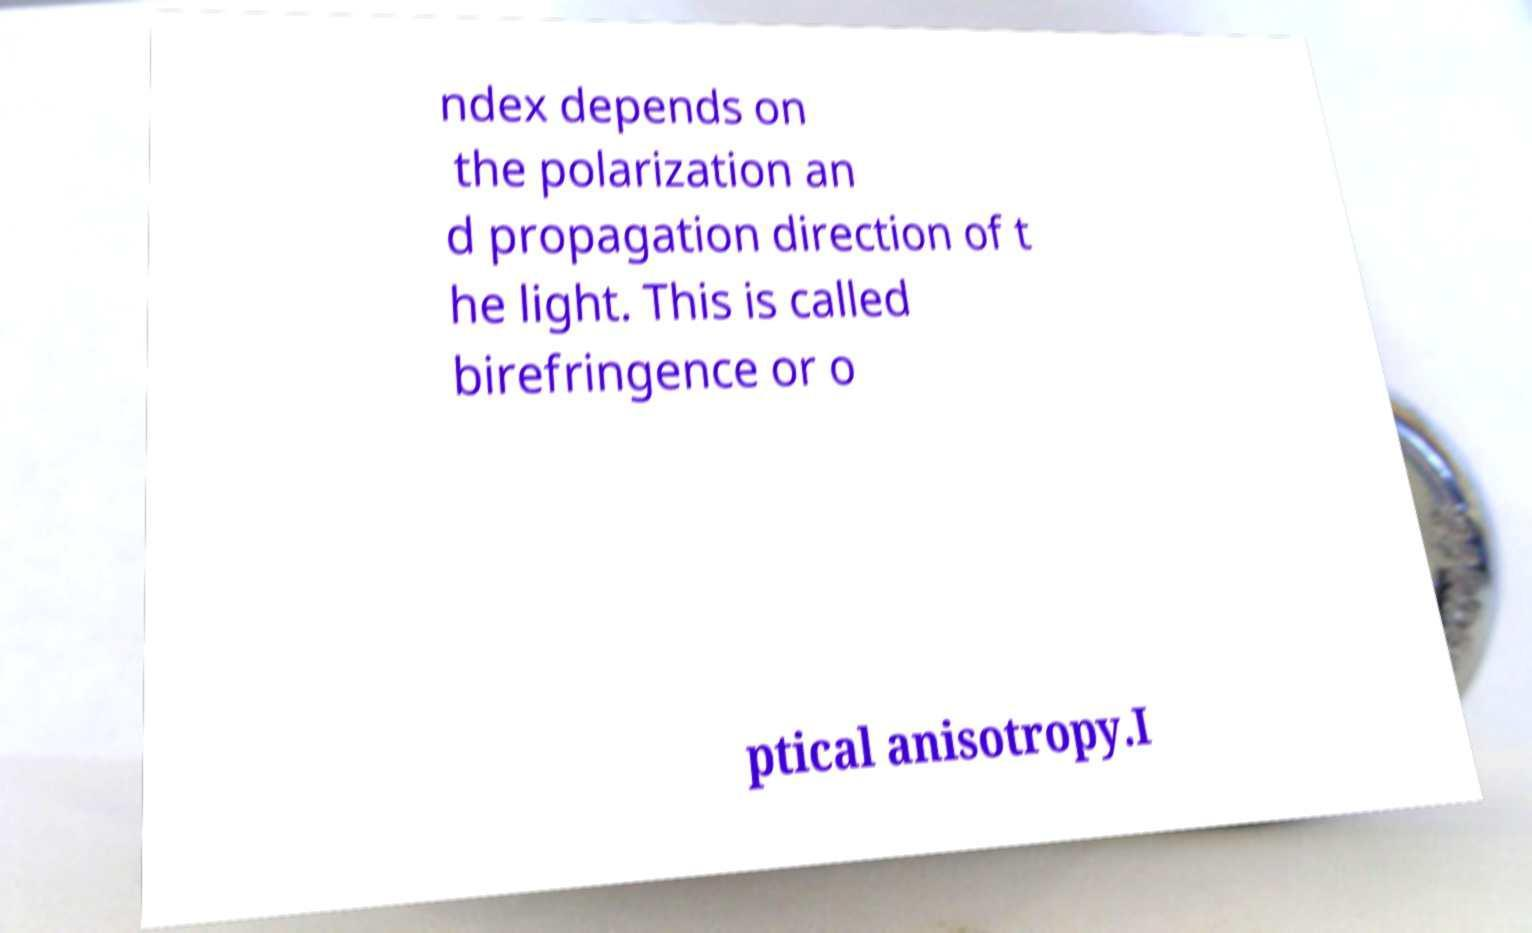What messages or text are displayed in this image? I need them in a readable, typed format. ndex depends on the polarization an d propagation direction of t he light. This is called birefringence or o ptical anisotropy.I 